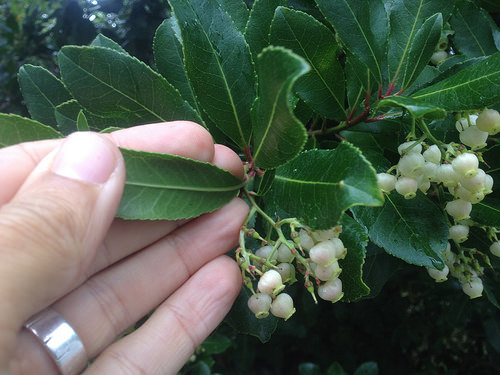<image>
Is there a thumb in front of the finger? Yes. The thumb is positioned in front of the finger, appearing closer to the camera viewpoint. 